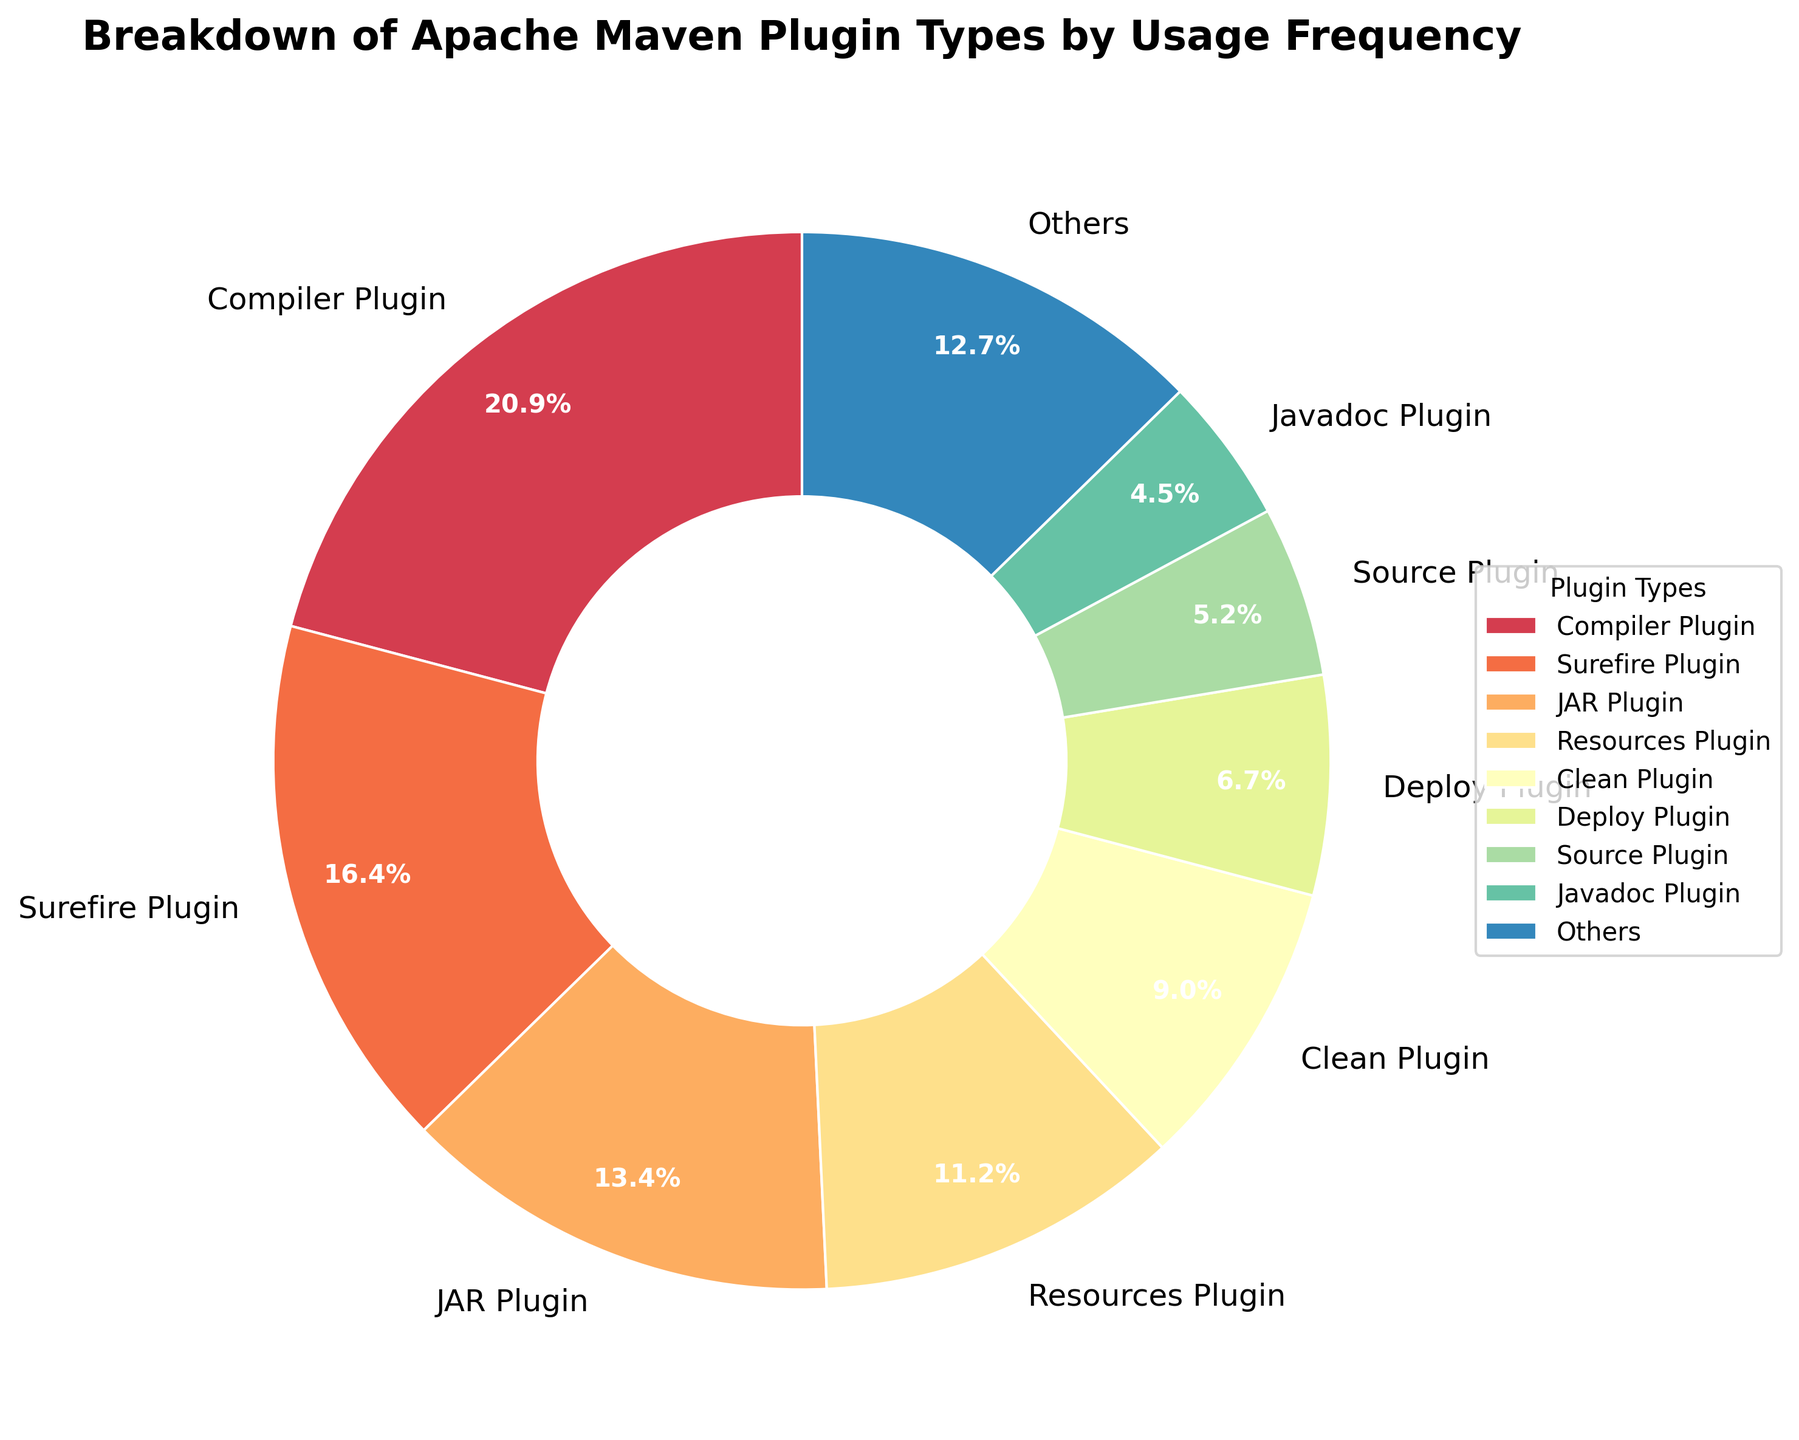Which plugin type has the highest usage frequency? The pie chart shows the "Compiler Plugin" as the largest segment, indicating it has the highest usage frequency.
Answer: Compiler Plugin How much higher is the usage frequency of the Compiler Plugin compared to the JAR Plugin? From the pie chart, the Compiler Plugin has a usage frequency of 28, and the JAR Plugin has a usage frequency of 18. The difference is 28 - 18 = 10.
Answer: 10 What percentage of the total usage do the Compiler Plugin and Surefire Plugin together represent? The Compiler Plugin represents 28 and the Surefire Plugin represents 22. The sum is 28 + 22 = 50. To find the percentage: (50 / total usage frequency) * 100 = (50 / 136) * 100 ≈ 36.8%.
Answer: 36.8% What is the usage frequency of plugins grouped under "Others"? All plugins except the top 8 are grouped under "Others" on the pie chart. The plugins in the "Others" category are Deploy Plugin, Source Plugin, Javadoc Plugin, Assembly Plugin, Dependency Plugin, Enforcer Plugin, Release Plugin, and Shade Plugin, War Plugin. Their individual frequencies are 9, 7, 6, 5, 4, 3, 2, 2, and 1 respectively. Summing them gives 9 + 7 + 6 + 5 + 4 + 3 + 2 + 2 + 1 = 39.
Answer: 39 Is the usage frequency of the Surefire Plugin higher or lower than the combined usage frequency of the Clean and Deploy plugins? The pie chart shows the Surefire Plugin has a usage frequency of 22. The Clean Plugin has a frequency of 12 and the Deploy Plugin has 9. Combined, Clean and Deploy have 12 + 9 = 21. Since 22 (Surefire) > 21 (Clean + Deploy), the Surefire Plugin is higher.
Answer: Higher How many plugin types have a usage frequency of 10 or more? From the pie chart, we count each segment with a frequency of 10 or higher: Compiler Plugin (28), Surefire Plugin (22), JAR Plugin (18), Resources Plugin (15), and Clean Plugin (12). There are 5 such plugin types.
Answer: 5 What is the average usage frequency of the top 8 plugin types? The top 8 plugin types and their frequencies are: Compiler (28), Surefire (22), JAR (18), Resources (15), Clean (12), Deploy (9), Source (7), Javadoc (6). Summing these gives 28 + 22 + 18 + 15 + 12 + 9 + 7 + 6 = 117. Dividing by 8 gives 117 / 8 ≈ 14.63.
Answer: 14.63 Which plugin type is represented by the smallest segment on the pie chart? The smallest segment on the pie chart represents the War Plugin with a usage frequency of 1.
Answer: War Plugin What can you conclude if Compiler Plugin and JAR Plugin were combined into one category? Combining Compiler Plugin (28) and JAR Plugin (18) would give a total of 28 + 18 = 46. Given that the entire set of plugins total 136, the combined percentage would be (46 / 136) * 100 ≈ 33.8%, making it the highest representation in the pie chart.
Answer: 33.8% What is the difference in the combined usage frequency of the top three plugin types and the plugin types grouped under "Others"? The top three plugin types have frequencies: Compiler (28), Surefire (22), and JAR (18), leading to a combined usage of 28 + 22 + 18 = 68. The "Others" group aggregates to 39. The difference is 68 - 39 = 29.
Answer: 29 